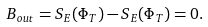Convert formula to latex. <formula><loc_0><loc_0><loc_500><loc_500>B _ { o u t } = S _ { E } ( \Phi _ { T } ) - S _ { E } ( \Phi _ { T } ) = 0 .</formula> 